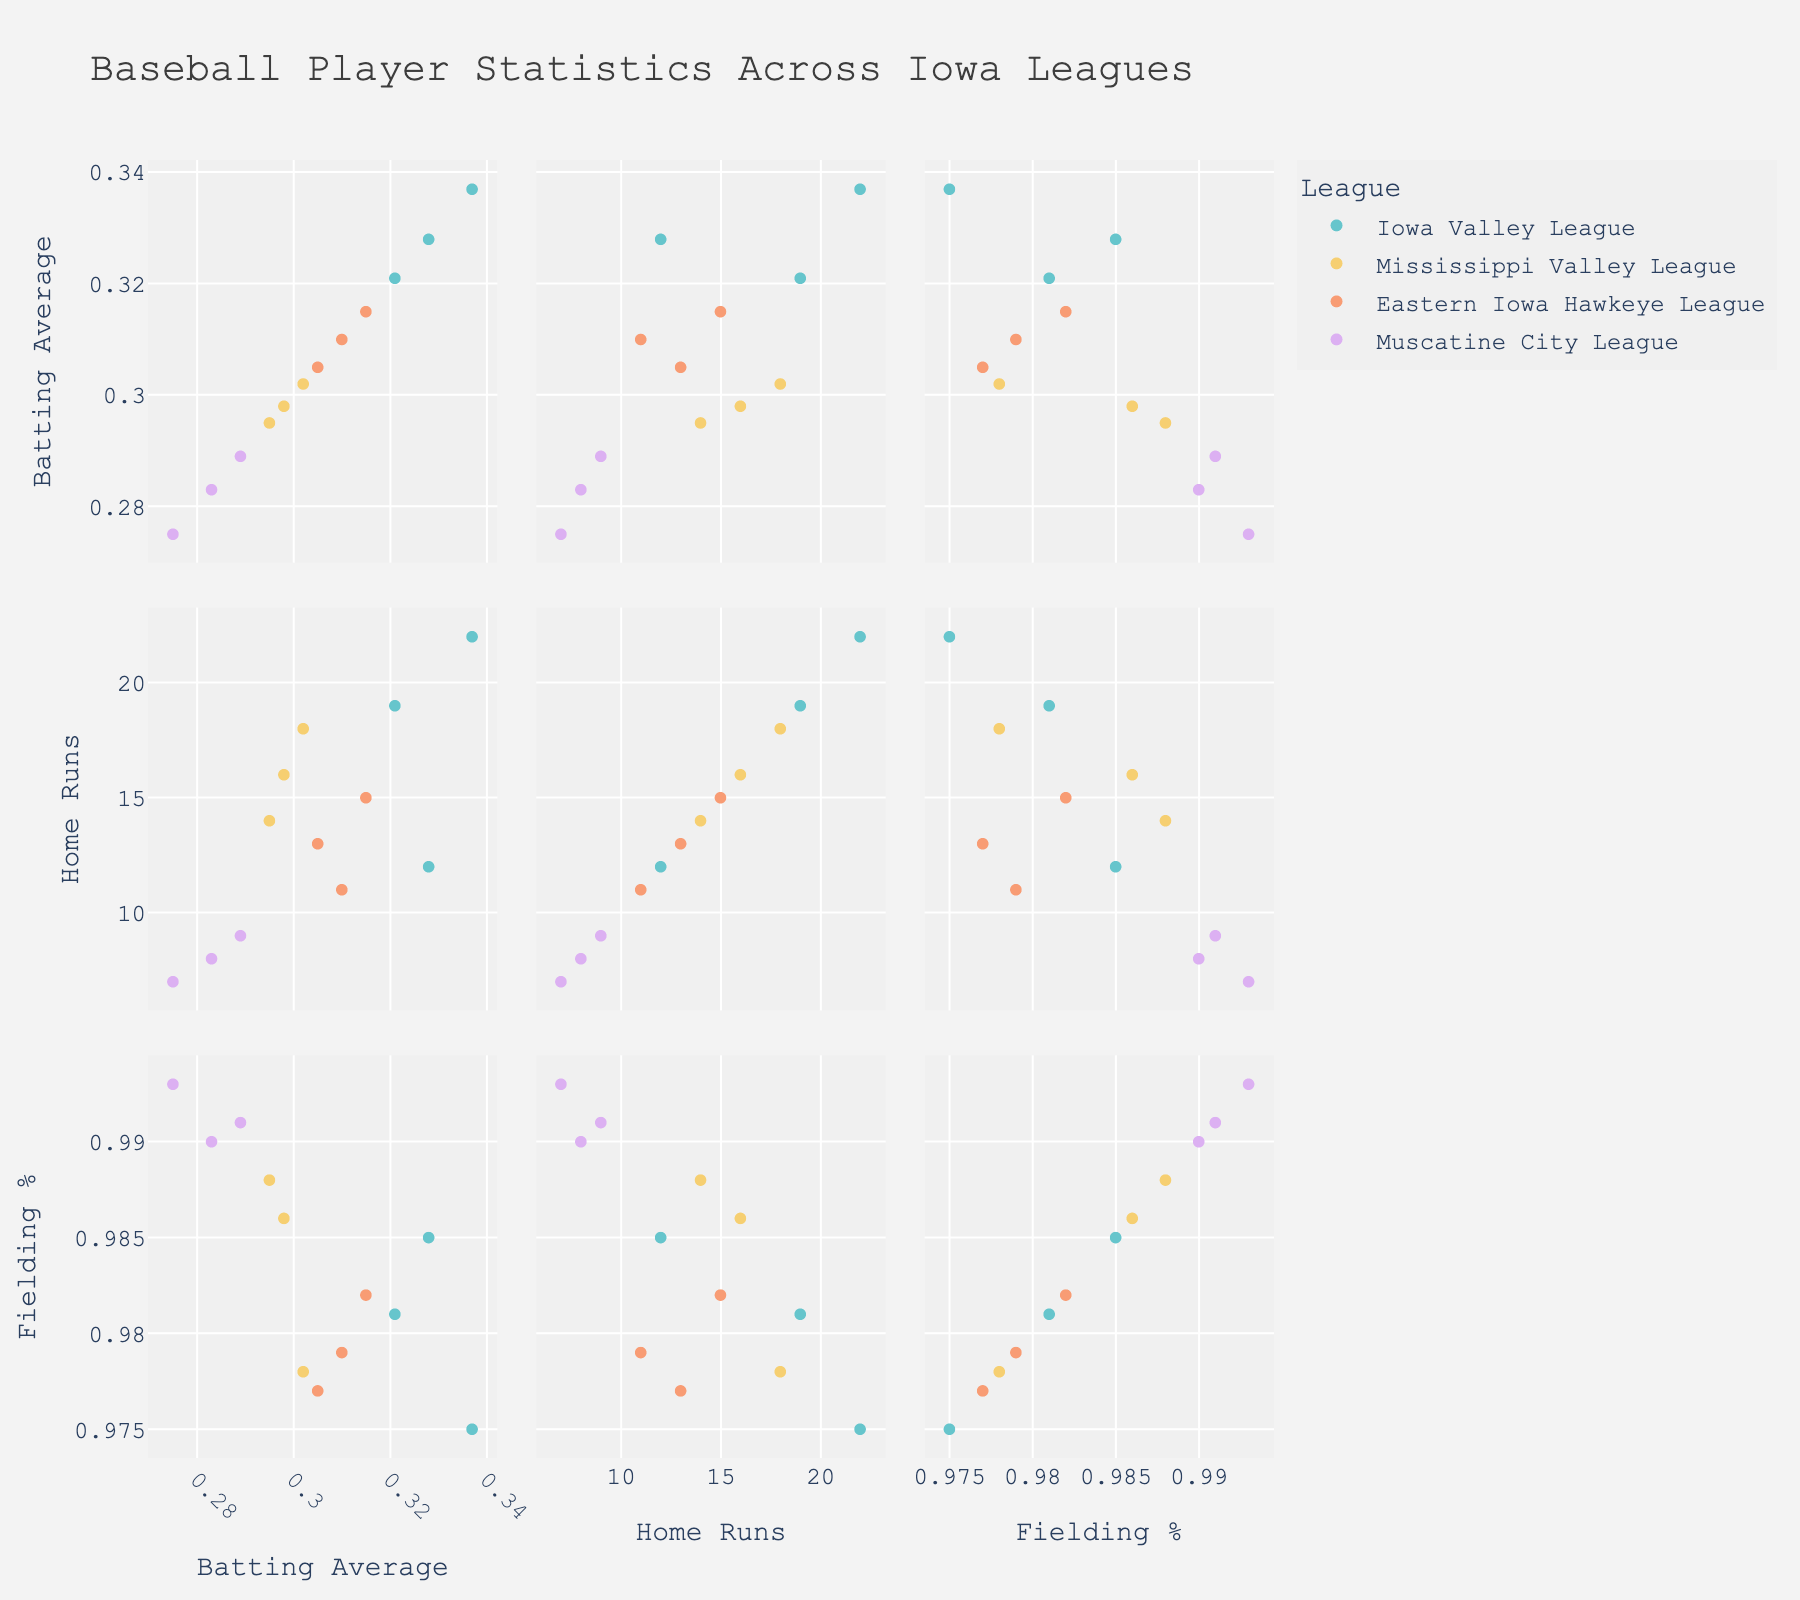what is the title of the figure? The title is "Allocation of Training Time for Different Hurling Skills" which is displayed at the top center of the figure.
Answer: Allocation of Training Time for Different Hurling Skills What skill takes up the largest percentage of training time in the overall distribution? The skill labeled with the largest segment in the overall distribution pie chart represents the largest percentage of training time, which is "Striking practice".
Answer: Striking practice How much total time is spent on "Tactical game play" and "Hand passing drills"? Summing the time spent on "Tactical game play" (2 hours) and "Hand passing drills" (1.5 hours) results in a total of 3.5 hours.
Answer: 3.5 hours Which chart displays the smallest segment for a single skill, and what is that skill? The chart named "Bottom 4 Skills" displays the smallest segment for "Goalkeeping (for some players)" which is 1 hour.
Answer: Bottom 4 Skills, Goalkeeping (for some players) Is more time devoted to "Fitness and conditioning" or "Strength training"? By comparing the slices, "Fitness and conditioning" is 3 hours, and "Strength training" is 2 hours, hence more time is devoted to "Fitness and conditioning".
Answer: Fitness and conditioning Which skill appears in the "Mid 3 Skills" chart, and how much training time is allocated to it? Referring to the "Mid 3 Skills" chart, the skills are "Hand passing drills" (1.5 hours), "Ball control and solo runs" (2 hours), and "Strength training" (2 hours).
Answer: Hand passing drills, Ball control and solo runs, and Strength training What proportion of time is allocated to "Match analysis and video review" in relation to "Team strategy sessions"? The time for "Match analysis and video review" is 1 hour, and for "Team strategy sessions" is 1 hour; both skills have the same allocated time.
Answer: Equal Between "Flexibility and stretching" and "Tactical game play”, which requires more training time and by how much? "Flexibility and stretching" (1.5 hours) compared to "Tactical game play" (2 hours) is less by 0.5 hours.
Answer: Tactical game play by 0.5 hours Which pie chart specifically details the distribution of the top three skills? The upper-left pie chart is labeled "Top 3 Skills" and it details the distribution of the top three skills.
Answer: Top 3 Skills What fraction of the total training time is spent on "Fitness and conditioning"? Out of 19 hours total training time, "Fitness and conditioning" (3 hours) makes up 3/19 or approximately 0.158.
Answer: 3/19 